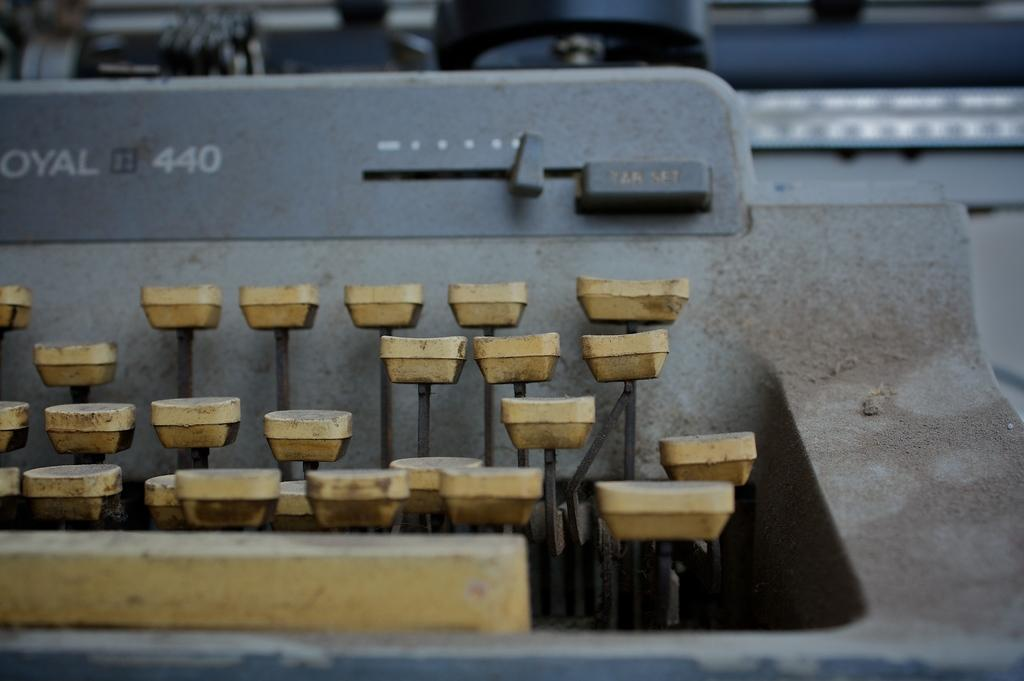<image>
Describe the image concisely. An old typewriter has 440 on the front above the keys. 